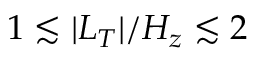<formula> <loc_0><loc_0><loc_500><loc_500>1 \lesssim | L _ { T } | / H _ { z } \lesssim 2</formula> 